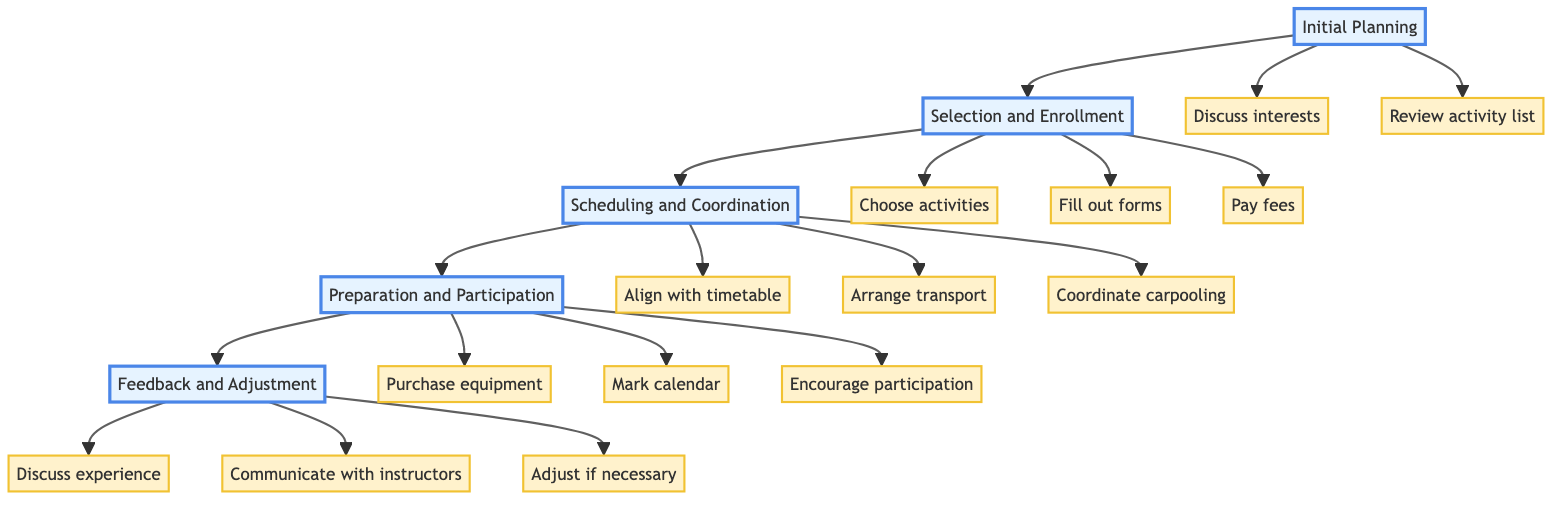What are the stages in the Clinical Pathway? By visually analyzing the diagram, I can see five stages listed in order from initial to final: Initial Planning, Selection and Enrollment, Scheduling and Coordination, Preparation and Participation, and Feedback and Adjustment.
Answer: Initial Planning, Selection and Enrollment, Scheduling and Coordination, Preparation and Participation, Feedback and Adjustment How many tasks are associated with the Scheduling and Coordination stage? Looking at the Scheduling and Coordination stage, I count three associated tasks: Align activities with school timetable, Arrange transportation if needed, and Coordinate with other parents for carpooling.
Answer: 3 Which stage follows Initial Planning? Following the flow of the diagram, the stage that comes immediately after Initial Planning is Selection and Enrollment, as indicated by the arrow connecting the two stages.
Answer: Selection and Enrollment What is one of the tasks in the Feedback and Adjustment stage? In the Feedback and Adjustment stage, one of the tasks listed is: Discuss child's experience, which is specifically associated with this stage.
Answer: Discuss child's experience How many tasks are there in the Selection and Enrollment stage? In the Selection and Enrollment stage, there are three tasks listed: Choose activities, Fill out enrollment forms, and Pay necessary fees, making a total of three tasks for this stage.
Answer: 3 What stage requires purchasing equipment or uniforms? The Preparation and Participation stage includes the task of Purchasing equipment or uniforms, as it is crucial for preparing for participation in the selected activities.
Answer: Preparation and Participation Which task comes before Arranging transportation? The task Align activities with school timetable precedes the task Arranging transportation in the Scheduling and Coordination stage, as indicated by the flow of the diagram connecting the tasks.
Answer: Align activities with school timetable What is the final stage in the Clinical Pathway? The last stage in this clinical pathway is Feedback and Adjustment, as shown at the end of the progression from Initial Planning through to this final stage.
Answer: Feedback and Adjustment What is the relationship between Discussions about interest and Reviewing the activity list? Discussions about interests with the child and Reviewing the activity list both occur in the Initial Planning stage, indicating they are part of the same process of gathering information before making selections.
Answer: Initial Planning 